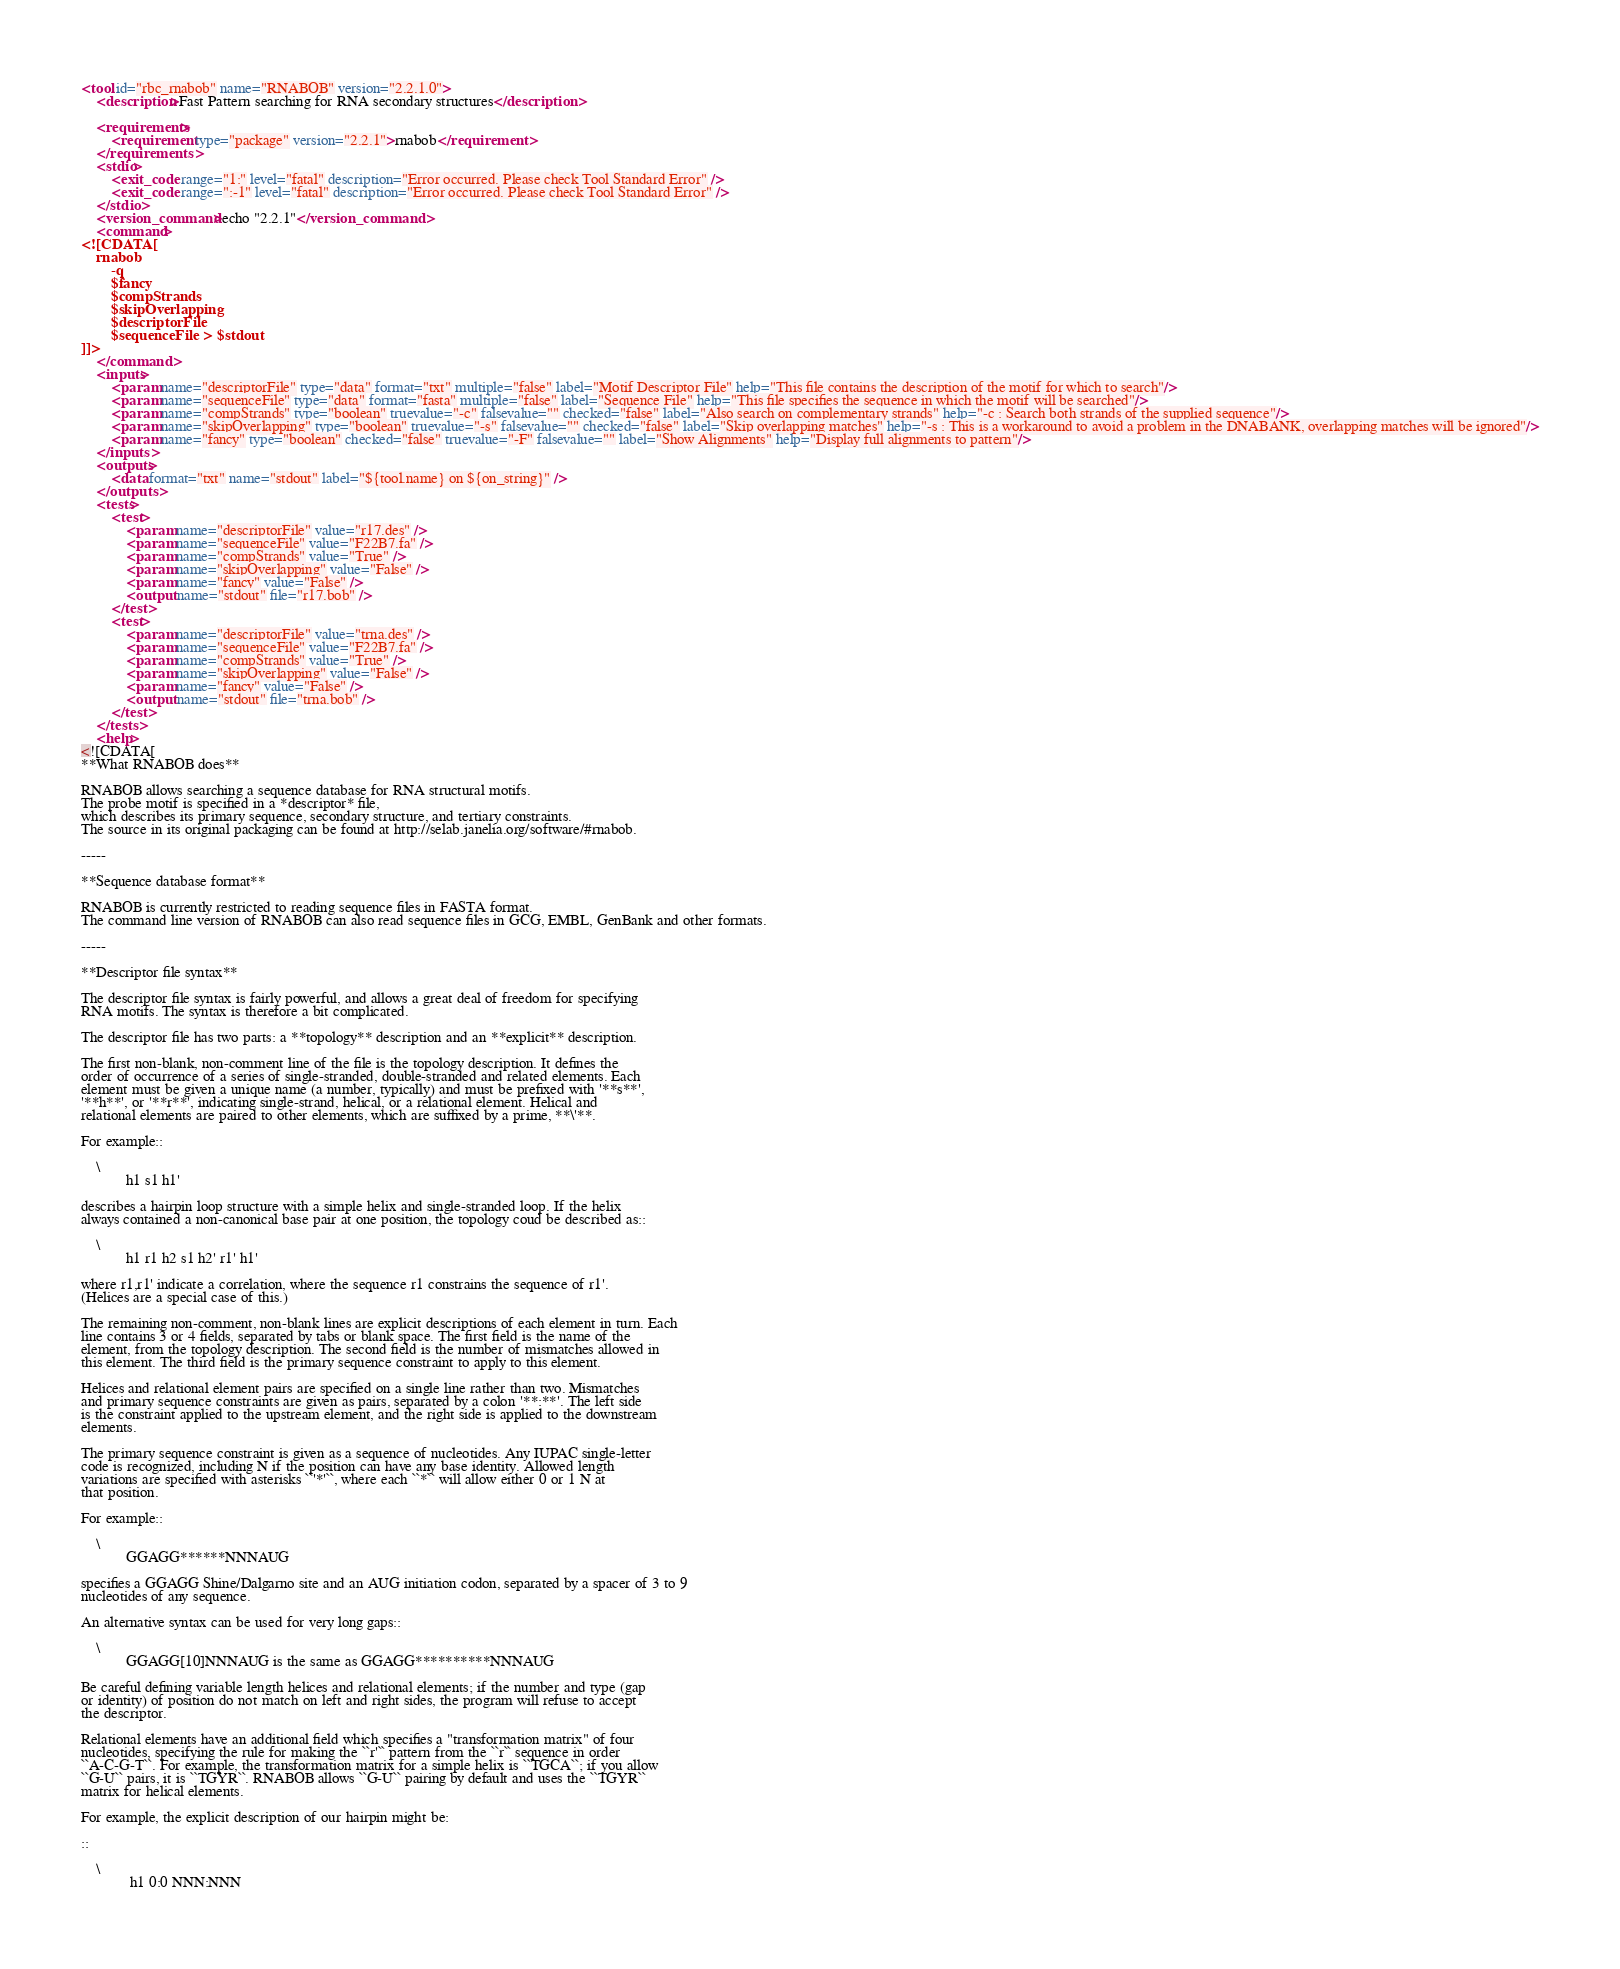Convert code to text. <code><loc_0><loc_0><loc_500><loc_500><_XML_><tool id="rbc_rnabob" name="RNABOB" version="2.2.1.0">
    <description>Fast Pattern searching for RNA secondary structures</description>

    <requirements>
        <requirement type="package" version="2.2.1">rnabob</requirement>
    </requirements>
    <stdio>
        <exit_code range="1:" level="fatal" description="Error occurred. Please check Tool Standard Error" />
        <exit_code range=":-1" level="fatal" description="Error occurred. Please check Tool Standard Error" />
    </stdio>
    <version_command>echo "2.2.1"</version_command>
    <command>
<![CDATA[
    rnabob
        -q
        $fancy
        $compStrands
        $skipOverlapping
        $descriptorFile
        $sequenceFile > $stdout
]]>
    </command>
    <inputs>
        <param name="descriptorFile" type="data" format="txt" multiple="false" label="Motif Descriptor File" help="This file contains the description of the motif for which to search"/>
        <param name="sequenceFile" type="data" format="fasta" multiple="false" label="Sequence File" help="This file specifies the sequence in which the motif will be searched"/>
        <param name="compStrands" type="boolean" truevalue="-c" falsevalue="" checked="false" label="Also search on complementary strands" help="-c : Search both strands of the supplied sequence"/>
        <param name="skipOverlapping" type="boolean" truevalue="-s" falsevalue="" checked="false" label="Skip overlapping matches" help="-s : This is a workaround to avoid a problem in the DNABANK, overlapping matches will be ignored"/>
        <param name="fancy" type="boolean" checked="false" truevalue="-F" falsevalue="" label="Show Alignments" help="Display full alignments to pattern"/>
    </inputs>
    <outputs>
        <data format="txt" name="stdout" label="${tool.name} on ${on_string}" />
    </outputs>
    <tests>
        <test>
            <param name="descriptorFile" value="r17.des" />
            <param name="sequenceFile" value="F22B7.fa" />
            <param name="compStrands" value="True" />
            <param name="skipOverlapping" value="False" />
            <param name="fancy" value="False" />
            <output name="stdout" file="r17.bob" />
        </test>
        <test>
            <param name="descriptorFile" value="trna.des" />
            <param name="sequenceFile" value="F22B7.fa" />
            <param name="compStrands" value="True" />
            <param name="skipOverlapping" value="False" />
            <param name="fancy" value="False" />
            <output name="stdout" file="trna.bob" />
        </test>
    </tests>
    <help>
<![CDATA[
**What RNABOB does**

RNABOB allows searching a sequence database for RNA structural motifs.
The probe motif is specified in a *descriptor* file,
which describes its primary sequence, secondary structure, and tertiary constraints.
The source in its original packaging can be found at http://selab.janelia.org/software/#rnabob.

-----

**Sequence database format**

RNABOB is currently restricted to reading sequence files in FASTA format.
The command line version of RNABOB can also read sequence files in GCG, EMBL, GenBank and other formats.

-----

**Descriptor file syntax**

The descriptor file syntax is fairly powerful, and allows a great deal of freedom for specifying
RNA motifs. The syntax is therefore a bit complicated.

The descriptor file has two parts: a **topology** description and an **explicit** description.

The first non-blank, non-comment line of the file is the topology description. It defines the
order of occurrence of a series of single-stranded, double-stranded and related elements. Each
element must be given a unique name (a number, typically) and must be prefixed with '**s**',
'**h**', or '**r**', indicating single-strand, helical, or a relational element. Helical and
relational elements are paired to other elements, which are suffixed by a prime, **\'**.

For example::

    \
            h1 s1 h1'

describes a hairpin loop structure with a simple helix and single-stranded loop. If the helix
always contained a non-canonical base pair at one position, the topology coud be described as::

    \
            h1 r1 h2 s1 h2' r1' h1'

where r1,r1' indicate a correlation, where the sequence r1 constrains the sequence of r1'.
(Helices are a special case of this.)

The remaining non-comment, non-blank lines are explicit descriptions of each element in turn. Each
line contains 3 or 4 fields, separated by tabs or blank space. The first field is the name of the
element, from the topology description. The second field is the number of mismatches allowed in
this element. The third field is the primary sequence constraint to apply to this element.

Helices and relational element pairs are specified on a single line rather than two. Mismatches
and primary sequence constraints are given as pairs, separated by a colon '**:**'. The left side
is the constraint applied to the upstream element, and the right side is applied to the downstream
elements.

The primary sequence constraint is given as a sequence of nucleotides. Any IUPAC single-letter
code is recognized, including N if the position can have any base identity. Allowed length
variations are specified with asterisks ``'*'``, where each ``*`` will allow either 0 or 1 N at
that position.

For example::

    \
            GGAGG******NNNAUG

specifies a GGAGG Shine/Dalgarno site and an AUG initiation codon, separated by a spacer of 3 to 9
nucleotides of any sequence.

An alternative syntax can be used for very long gaps::

    \
            GGAGG[10]NNNAUG is the same as GGAGG**********NNNAUG

Be careful defining variable length helices and relational elements; if the number and type (gap
or identity) of position do not match on left and right sides, the program will refuse to accept
the descriptor.

Relational elements have an additional field which specifies a "transformation matrix" of four
nucleotides, specifying the rule for making the ``r'`` pattern from the ``r`` sequence in order
``A-C-G-T``. For example, the transformation matrix for a simple helix is ``TGCA``; if you allow
``G-U`` pairs, it is ``TGYR``. RNABOB allows ``G-U`` pairing by default and uses the ``TGYR``
matrix for helical elements.

For example, the explicit description of our hairpin might be:

::

    \
             h1 0:0 NNN:NNN</code> 